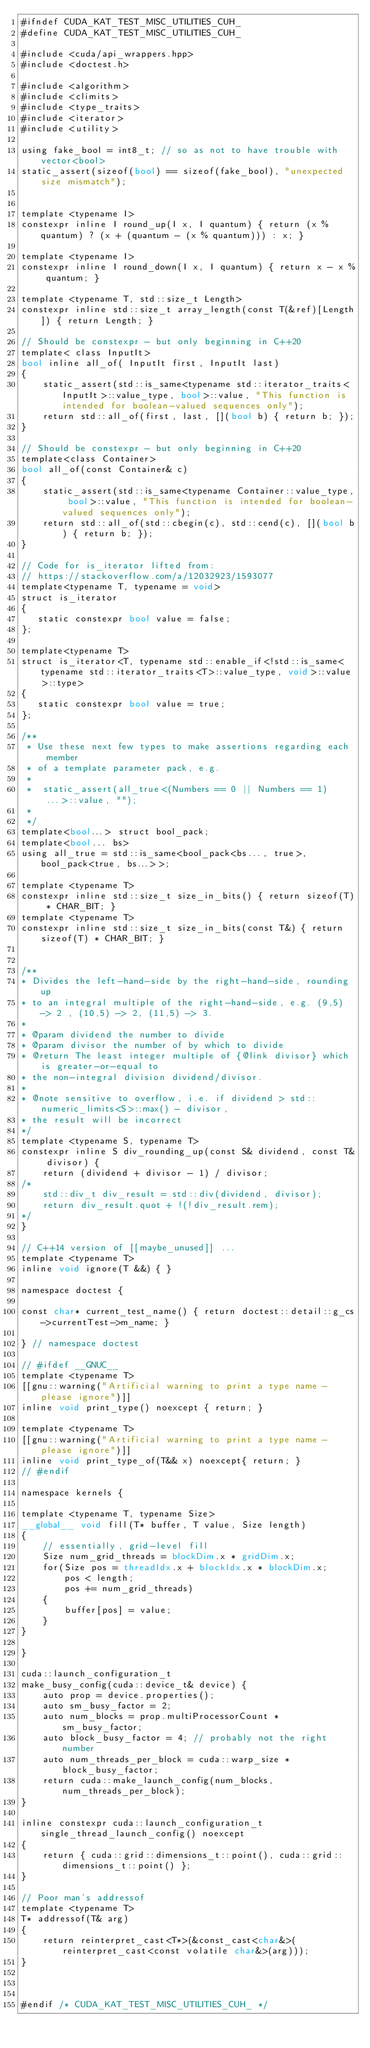Convert code to text. <code><loc_0><loc_0><loc_500><loc_500><_Cuda_>#ifndef CUDA_KAT_TEST_MISC_UTILITIES_CUH_
#define CUDA_KAT_TEST_MISC_UTILITIES_CUH_

#include <cuda/api_wrappers.hpp>
#include <doctest.h>

#include <algorithm>
#include <climits>
#include <type_traits>
#include <iterator>
#include <utility>

using fake_bool = int8_t; // so as not to have trouble with vector<bool>
static_assert(sizeof(bool) == sizeof(fake_bool), "unexpected size mismatch");


template <typename I>
constexpr inline I round_up(I x, I quantum) { return (x % quantum) ? (x + (quantum - (x % quantum))) : x; }

template <typename I>
constexpr inline I round_down(I x, I quantum) { return x - x % quantum; }

template <typename T, std::size_t Length>
constexpr inline std::size_t array_length(const T(&ref)[Length]) { return Length; }

// Should be constexpr - but only beginning in C++20
template< class InputIt>
bool inline all_of( InputIt first, InputIt last)
{
	static_assert(std::is_same<typename std::iterator_traits<InputIt>::value_type, bool>::value, "This function is intended for boolean-valued sequences only");
	return std::all_of(first, last, [](bool b) { return b; });
}

// Should be constexpr - but only beginning in C++20
template<class Container>
bool all_of(const Container& c)
{
	static_assert(std::is_same<typename Container::value_type, bool>::value, "This function is intended for boolean-valued sequences only");
	return std::all_of(std::cbegin(c), std::cend(c), [](bool b) { return b; });
}

// Code for is_iterator lifted from:
// https://stackoverflow.com/a/12032923/1593077
template<typename T, typename = void>
struct is_iterator
{
   static constexpr bool value = false;
};

template<typename T>
struct is_iterator<T, typename std::enable_if<!std::is_same<typename std::iterator_traits<T>::value_type, void>::value>::type>
{
   static constexpr bool value = true;
};

/**
 * Use these next few types to make assertions regarding each member
 * of a template parameter pack, e.g.
 *
 *  static_assert(all_true<(Numbers == 0 || Numbers == 1)...>::value, "");
 *
 */
template<bool...> struct bool_pack;
template<bool... bs>
using all_true = std::is_same<bool_pack<bs..., true>, bool_pack<true, bs...>>;

template <typename T>
constexpr inline std::size_t size_in_bits() { return sizeof(T) * CHAR_BIT; }
template <typename T>
constexpr inline std::size_t size_in_bits(const T&) { return sizeof(T) * CHAR_BIT; }


/**
* Divides the left-hand-side by the right-hand-side, rounding up
* to an integral multiple of the right-hand-side, e.g. (9,5) -> 2 , (10,5) -> 2, (11,5) -> 3.
*
* @param dividend the number to divide
* @param divisor the number of by which to divide
* @return The least integer multiple of {@link divisor} which is greater-or-equal to
* the non-integral division dividend/divisor.
*
* @note sensitive to overflow, i.e. if dividend > std::numeric_limits<S>::max() - divisor,
* the result will be incorrect
*/
template <typename S, typename T>
constexpr inline S div_rounding_up(const S& dividend, const T& divisor) {
	return (dividend + divisor - 1) / divisor;
/*
	std::div_t div_result = std::div(dividend, divisor);
	return div_result.quot + !(!div_result.rem);
*/
}

// C++14 version of [[maybe_unused]] ...
template <typename T>
inline void ignore(T &&) { }

namespace doctest {

const char* current_test_name() { return doctest::detail::g_cs->currentTest->m_name; }

} // namespace doctest

// #ifdef __GNUC__
template <typename T>
[[gnu::warning("Artificial warning to print a type name - please ignore")]]
inline void print_type() noexcept { return; }

template <typename T>
[[gnu::warning("Artificial warning to print a type name - please ignore")]]
inline void print_type_of(T&& x) noexcept{ return; }
// #endif

namespace kernels {

template <typename T, typename Size>
__global__ void fill(T* buffer, T value, Size length)
{
	// essentially, grid-level fill
	Size num_grid_threads = blockDim.x * gridDim.x;
	for(Size pos = threadIdx.x + blockIdx.x * blockDim.x;
		pos < length;
		pos += num_grid_threads)
	{
		buffer[pos] = value;
	}
}

}

cuda::launch_configuration_t
make_busy_config(cuda::device_t& device) {
	auto prop = device.properties();
	auto sm_busy_factor = 2;
	auto num_blocks = prop.multiProcessorCount * sm_busy_factor;
	auto block_busy_factor = 4; // probably not the right number
	auto num_threads_per_block = cuda::warp_size * block_busy_factor;
	return cuda::make_launch_config(num_blocks, num_threads_per_block);
}

inline constexpr cuda::launch_configuration_t single_thread_launch_config() noexcept
{
	return { cuda::grid::dimensions_t::point(), cuda::grid::dimensions_t::point() };
}

// Poor man's addressof
template <typename T>
T* addressof(T& arg)
{
	return reinterpret_cast<T*>(&const_cast<char&>(reinterpret_cast<const volatile char&>(arg)));
}



#endif /* CUDA_KAT_TEST_MISC_UTILITIES_CUH_ */
</code> 